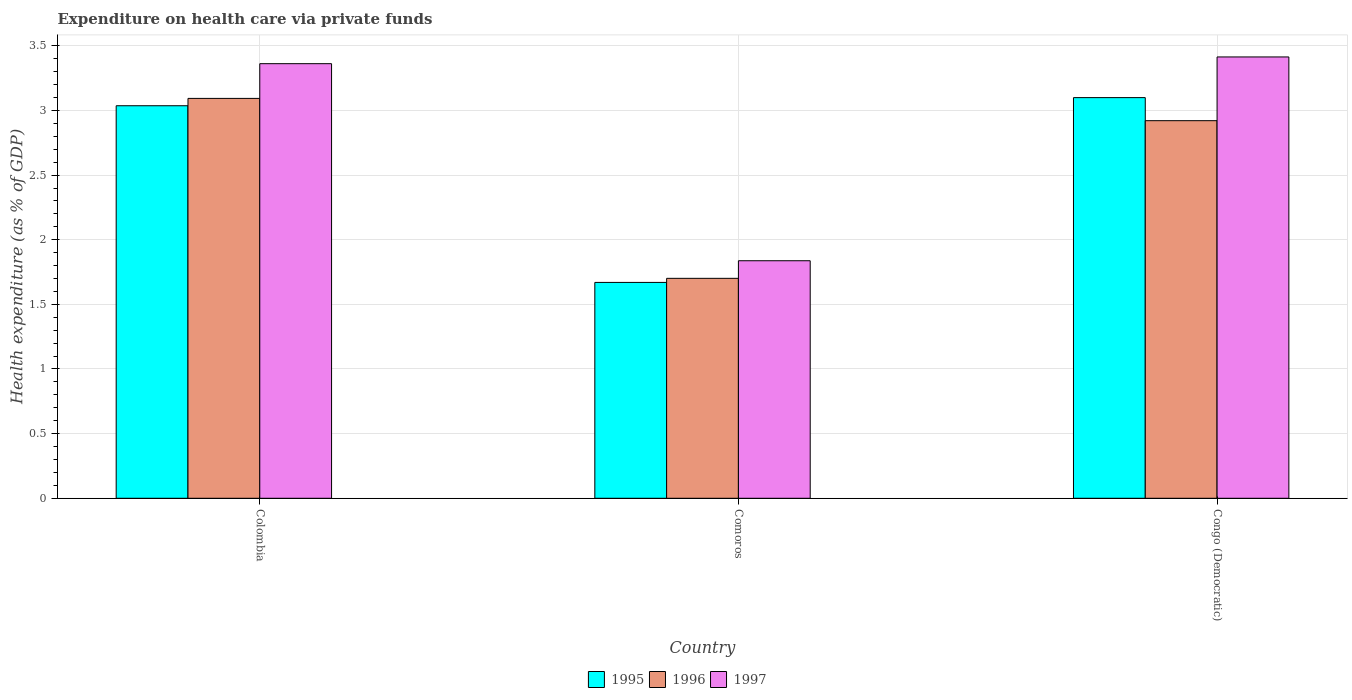How many different coloured bars are there?
Keep it short and to the point. 3. Are the number of bars per tick equal to the number of legend labels?
Provide a succinct answer. Yes. Are the number of bars on each tick of the X-axis equal?
Provide a short and direct response. Yes. How many bars are there on the 2nd tick from the left?
Offer a very short reply. 3. How many bars are there on the 1st tick from the right?
Give a very brief answer. 3. What is the label of the 3rd group of bars from the left?
Give a very brief answer. Congo (Democratic). What is the expenditure made on health care in 1996 in Colombia?
Keep it short and to the point. 3.09. Across all countries, what is the maximum expenditure made on health care in 1997?
Give a very brief answer. 3.41. Across all countries, what is the minimum expenditure made on health care in 1995?
Offer a very short reply. 1.67. In which country was the expenditure made on health care in 1995 maximum?
Offer a terse response. Congo (Democratic). In which country was the expenditure made on health care in 1996 minimum?
Give a very brief answer. Comoros. What is the total expenditure made on health care in 1995 in the graph?
Your answer should be compact. 7.81. What is the difference between the expenditure made on health care in 1995 in Colombia and that in Congo (Democratic)?
Offer a terse response. -0.06. What is the difference between the expenditure made on health care in 1997 in Comoros and the expenditure made on health care in 1996 in Colombia?
Give a very brief answer. -1.26. What is the average expenditure made on health care in 1997 per country?
Provide a short and direct response. 2.87. What is the difference between the expenditure made on health care of/in 1996 and expenditure made on health care of/in 1997 in Colombia?
Your answer should be very brief. -0.27. In how many countries, is the expenditure made on health care in 1996 greater than 0.7 %?
Your answer should be compact. 3. What is the ratio of the expenditure made on health care in 1997 in Comoros to that in Congo (Democratic)?
Make the answer very short. 0.54. Is the expenditure made on health care in 1997 in Comoros less than that in Congo (Democratic)?
Give a very brief answer. Yes. Is the difference between the expenditure made on health care in 1996 in Colombia and Comoros greater than the difference between the expenditure made on health care in 1997 in Colombia and Comoros?
Offer a very short reply. No. What is the difference between the highest and the second highest expenditure made on health care in 1996?
Provide a short and direct response. -1.22. What is the difference between the highest and the lowest expenditure made on health care in 1995?
Your response must be concise. 1.43. In how many countries, is the expenditure made on health care in 1996 greater than the average expenditure made on health care in 1996 taken over all countries?
Your answer should be very brief. 2. What does the 2nd bar from the left in Comoros represents?
Ensure brevity in your answer.  1996. What does the 2nd bar from the right in Comoros represents?
Offer a terse response. 1996. How many bars are there?
Provide a succinct answer. 9. Does the graph contain grids?
Provide a succinct answer. Yes. Where does the legend appear in the graph?
Provide a succinct answer. Bottom center. How are the legend labels stacked?
Ensure brevity in your answer.  Horizontal. What is the title of the graph?
Make the answer very short. Expenditure on health care via private funds. Does "1999" appear as one of the legend labels in the graph?
Keep it short and to the point. No. What is the label or title of the Y-axis?
Provide a succinct answer. Health expenditure (as % of GDP). What is the Health expenditure (as % of GDP) of 1995 in Colombia?
Give a very brief answer. 3.04. What is the Health expenditure (as % of GDP) of 1996 in Colombia?
Offer a very short reply. 3.09. What is the Health expenditure (as % of GDP) in 1997 in Colombia?
Offer a terse response. 3.36. What is the Health expenditure (as % of GDP) of 1995 in Comoros?
Provide a succinct answer. 1.67. What is the Health expenditure (as % of GDP) in 1996 in Comoros?
Your answer should be very brief. 1.7. What is the Health expenditure (as % of GDP) of 1997 in Comoros?
Offer a terse response. 1.84. What is the Health expenditure (as % of GDP) of 1995 in Congo (Democratic)?
Your answer should be very brief. 3.1. What is the Health expenditure (as % of GDP) of 1996 in Congo (Democratic)?
Give a very brief answer. 2.92. What is the Health expenditure (as % of GDP) in 1997 in Congo (Democratic)?
Give a very brief answer. 3.41. Across all countries, what is the maximum Health expenditure (as % of GDP) in 1995?
Your answer should be very brief. 3.1. Across all countries, what is the maximum Health expenditure (as % of GDP) in 1996?
Offer a terse response. 3.09. Across all countries, what is the maximum Health expenditure (as % of GDP) in 1997?
Make the answer very short. 3.41. Across all countries, what is the minimum Health expenditure (as % of GDP) in 1995?
Offer a terse response. 1.67. Across all countries, what is the minimum Health expenditure (as % of GDP) of 1996?
Provide a succinct answer. 1.7. Across all countries, what is the minimum Health expenditure (as % of GDP) of 1997?
Offer a very short reply. 1.84. What is the total Health expenditure (as % of GDP) in 1995 in the graph?
Your answer should be very brief. 7.81. What is the total Health expenditure (as % of GDP) in 1996 in the graph?
Offer a very short reply. 7.72. What is the total Health expenditure (as % of GDP) in 1997 in the graph?
Ensure brevity in your answer.  8.61. What is the difference between the Health expenditure (as % of GDP) in 1995 in Colombia and that in Comoros?
Offer a terse response. 1.37. What is the difference between the Health expenditure (as % of GDP) in 1996 in Colombia and that in Comoros?
Your answer should be compact. 1.39. What is the difference between the Health expenditure (as % of GDP) in 1997 in Colombia and that in Comoros?
Offer a terse response. 1.52. What is the difference between the Health expenditure (as % of GDP) in 1995 in Colombia and that in Congo (Democratic)?
Ensure brevity in your answer.  -0.06. What is the difference between the Health expenditure (as % of GDP) in 1996 in Colombia and that in Congo (Democratic)?
Your answer should be very brief. 0.17. What is the difference between the Health expenditure (as % of GDP) in 1997 in Colombia and that in Congo (Democratic)?
Provide a succinct answer. -0.05. What is the difference between the Health expenditure (as % of GDP) in 1995 in Comoros and that in Congo (Democratic)?
Provide a succinct answer. -1.43. What is the difference between the Health expenditure (as % of GDP) of 1996 in Comoros and that in Congo (Democratic)?
Make the answer very short. -1.22. What is the difference between the Health expenditure (as % of GDP) in 1997 in Comoros and that in Congo (Democratic)?
Make the answer very short. -1.58. What is the difference between the Health expenditure (as % of GDP) of 1995 in Colombia and the Health expenditure (as % of GDP) of 1996 in Comoros?
Give a very brief answer. 1.33. What is the difference between the Health expenditure (as % of GDP) in 1995 in Colombia and the Health expenditure (as % of GDP) in 1997 in Comoros?
Offer a terse response. 1.2. What is the difference between the Health expenditure (as % of GDP) of 1996 in Colombia and the Health expenditure (as % of GDP) of 1997 in Comoros?
Provide a short and direct response. 1.26. What is the difference between the Health expenditure (as % of GDP) in 1995 in Colombia and the Health expenditure (as % of GDP) in 1996 in Congo (Democratic)?
Keep it short and to the point. 0.12. What is the difference between the Health expenditure (as % of GDP) of 1995 in Colombia and the Health expenditure (as % of GDP) of 1997 in Congo (Democratic)?
Your response must be concise. -0.38. What is the difference between the Health expenditure (as % of GDP) of 1996 in Colombia and the Health expenditure (as % of GDP) of 1997 in Congo (Democratic)?
Make the answer very short. -0.32. What is the difference between the Health expenditure (as % of GDP) of 1995 in Comoros and the Health expenditure (as % of GDP) of 1996 in Congo (Democratic)?
Ensure brevity in your answer.  -1.25. What is the difference between the Health expenditure (as % of GDP) in 1995 in Comoros and the Health expenditure (as % of GDP) in 1997 in Congo (Democratic)?
Provide a short and direct response. -1.74. What is the difference between the Health expenditure (as % of GDP) of 1996 in Comoros and the Health expenditure (as % of GDP) of 1997 in Congo (Democratic)?
Your response must be concise. -1.71. What is the average Health expenditure (as % of GDP) of 1995 per country?
Your answer should be very brief. 2.6. What is the average Health expenditure (as % of GDP) of 1996 per country?
Your answer should be compact. 2.57. What is the average Health expenditure (as % of GDP) of 1997 per country?
Your answer should be very brief. 2.87. What is the difference between the Health expenditure (as % of GDP) in 1995 and Health expenditure (as % of GDP) in 1996 in Colombia?
Ensure brevity in your answer.  -0.06. What is the difference between the Health expenditure (as % of GDP) of 1995 and Health expenditure (as % of GDP) of 1997 in Colombia?
Give a very brief answer. -0.33. What is the difference between the Health expenditure (as % of GDP) of 1996 and Health expenditure (as % of GDP) of 1997 in Colombia?
Make the answer very short. -0.27. What is the difference between the Health expenditure (as % of GDP) of 1995 and Health expenditure (as % of GDP) of 1996 in Comoros?
Provide a succinct answer. -0.03. What is the difference between the Health expenditure (as % of GDP) of 1995 and Health expenditure (as % of GDP) of 1997 in Comoros?
Your answer should be very brief. -0.17. What is the difference between the Health expenditure (as % of GDP) of 1996 and Health expenditure (as % of GDP) of 1997 in Comoros?
Your answer should be very brief. -0.14. What is the difference between the Health expenditure (as % of GDP) in 1995 and Health expenditure (as % of GDP) in 1996 in Congo (Democratic)?
Offer a very short reply. 0.18. What is the difference between the Health expenditure (as % of GDP) in 1995 and Health expenditure (as % of GDP) in 1997 in Congo (Democratic)?
Give a very brief answer. -0.31. What is the difference between the Health expenditure (as % of GDP) in 1996 and Health expenditure (as % of GDP) in 1997 in Congo (Democratic)?
Ensure brevity in your answer.  -0.49. What is the ratio of the Health expenditure (as % of GDP) of 1995 in Colombia to that in Comoros?
Keep it short and to the point. 1.82. What is the ratio of the Health expenditure (as % of GDP) of 1996 in Colombia to that in Comoros?
Offer a very short reply. 1.82. What is the ratio of the Health expenditure (as % of GDP) in 1997 in Colombia to that in Comoros?
Give a very brief answer. 1.83. What is the ratio of the Health expenditure (as % of GDP) in 1995 in Colombia to that in Congo (Democratic)?
Your response must be concise. 0.98. What is the ratio of the Health expenditure (as % of GDP) of 1996 in Colombia to that in Congo (Democratic)?
Your answer should be very brief. 1.06. What is the ratio of the Health expenditure (as % of GDP) of 1997 in Colombia to that in Congo (Democratic)?
Give a very brief answer. 0.98. What is the ratio of the Health expenditure (as % of GDP) of 1995 in Comoros to that in Congo (Democratic)?
Offer a very short reply. 0.54. What is the ratio of the Health expenditure (as % of GDP) of 1996 in Comoros to that in Congo (Democratic)?
Keep it short and to the point. 0.58. What is the ratio of the Health expenditure (as % of GDP) of 1997 in Comoros to that in Congo (Democratic)?
Your answer should be very brief. 0.54. What is the difference between the highest and the second highest Health expenditure (as % of GDP) of 1995?
Ensure brevity in your answer.  0.06. What is the difference between the highest and the second highest Health expenditure (as % of GDP) of 1996?
Your answer should be very brief. 0.17. What is the difference between the highest and the second highest Health expenditure (as % of GDP) of 1997?
Keep it short and to the point. 0.05. What is the difference between the highest and the lowest Health expenditure (as % of GDP) of 1995?
Your answer should be very brief. 1.43. What is the difference between the highest and the lowest Health expenditure (as % of GDP) of 1996?
Provide a short and direct response. 1.39. What is the difference between the highest and the lowest Health expenditure (as % of GDP) of 1997?
Your answer should be very brief. 1.58. 